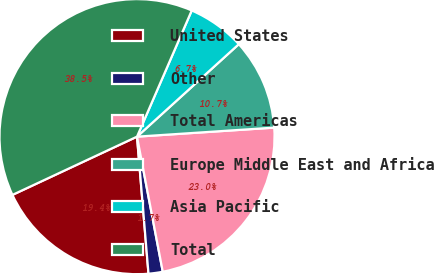Convert chart to OTSL. <chart><loc_0><loc_0><loc_500><loc_500><pie_chart><fcel>United States<fcel>Other<fcel>Total Americas<fcel>Europe Middle East and Africa<fcel>Asia Pacific<fcel>Total<nl><fcel>19.37%<fcel>1.67%<fcel>23.05%<fcel>10.69%<fcel>6.75%<fcel>38.48%<nl></chart> 